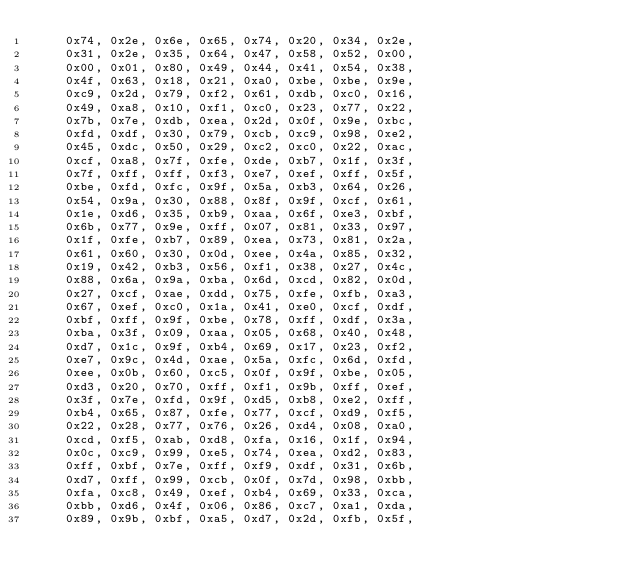Convert code to text. <code><loc_0><loc_0><loc_500><loc_500><_C_>	0x74, 0x2e, 0x6e, 0x65, 0x74, 0x20, 0x34, 0x2e,
	0x31, 0x2e, 0x35, 0x64, 0x47, 0x58, 0x52, 0x00,
	0x00, 0x01, 0x80, 0x49, 0x44, 0x41, 0x54, 0x38,
	0x4f, 0x63, 0x18, 0x21, 0xa0, 0xbe, 0xbe, 0x9e,
	0xc9, 0x2d, 0x79, 0xf2, 0x61, 0xdb, 0xc0, 0x16,
	0x49, 0xa8, 0x10, 0xf1, 0xc0, 0x23, 0x77, 0x22,
	0x7b, 0x7e, 0xdb, 0xea, 0x2d, 0x0f, 0x9e, 0xbc,
	0xfd, 0xdf, 0x30, 0x79, 0xcb, 0xc9, 0x98, 0xe2,
	0x45, 0xdc, 0x50, 0x29, 0xc2, 0xc0, 0x22, 0xac,
	0xcf, 0xa8, 0x7f, 0xfe, 0xde, 0xb7, 0x1f, 0x3f,
	0x7f, 0xff, 0xff, 0xf3, 0xe7, 0xef, 0xff, 0x5f,
	0xbe, 0xfd, 0xfc, 0x9f, 0x5a, 0xb3, 0x64, 0x26,
	0x54, 0x9a, 0x30, 0x88, 0x8f, 0x9f, 0xcf, 0x61,
	0x1e, 0xd6, 0x35, 0xb9, 0xaa, 0x6f, 0xe3, 0xbf,
	0x6b, 0x77, 0x9e, 0xff, 0x07, 0x81, 0x33, 0x97,
	0x1f, 0xfe, 0xb7, 0x89, 0xea, 0x73, 0x81, 0x2a,
	0x61, 0x60, 0x30, 0x0d, 0xee, 0x4a, 0x85, 0x32,
	0x19, 0x42, 0xb3, 0x56, 0xf1, 0x38, 0x27, 0x4c,
	0x88, 0x6a, 0x9a, 0xba, 0x6d, 0xcd, 0x82, 0x0d,
	0x27, 0xcf, 0xae, 0xdd, 0x75, 0xfe, 0xfb, 0xa3,
	0x67, 0xef, 0xc0, 0x1a, 0x41, 0xe0, 0xcf, 0xdf,
	0xbf, 0xff, 0x9f, 0xbe, 0x78, 0xff, 0xdf, 0x3a,
	0xba, 0x3f, 0x09, 0xaa, 0x05, 0x68, 0x40, 0x48,
	0xd7, 0x1c, 0x9f, 0xb4, 0x69, 0x17, 0x23, 0xf2,
	0xe7, 0x9c, 0x4d, 0xae, 0x5a, 0xfc, 0x6d, 0xfd,
	0xee, 0x0b, 0x60, 0xc5, 0x0f, 0x9f, 0xbe, 0x05,
	0xd3, 0x20, 0x70, 0xff, 0xf1, 0x9b, 0xff, 0xef,
	0x3f, 0x7e, 0xfd, 0x9f, 0xd5, 0xb8, 0xe2, 0xff,
	0xb4, 0x65, 0x87, 0xfe, 0x77, 0xcf, 0xd9, 0xf5,
	0x22, 0x28, 0x77, 0x76, 0x26, 0xd4, 0x08, 0xa0,
	0xcd, 0xf5, 0xab, 0xd8, 0xfa, 0x16, 0x1f, 0x94,
	0x0c, 0xc9, 0x99, 0xe5, 0x74, 0xea, 0xd2, 0x83,
	0xff, 0xbf, 0x7e, 0xff, 0xf9, 0xdf, 0x31, 0x6b,
	0xd7, 0xff, 0x99, 0xcb, 0x0f, 0x7d, 0x98, 0xbb,
	0xfa, 0xc8, 0x49, 0xef, 0xb4, 0x69, 0x33, 0xca,
	0xbb, 0xd6, 0x4f, 0x06, 0x86, 0xc7, 0xa1, 0xda,
	0x89, 0x9b, 0xbf, 0xa5, 0xd7, 0x2d, 0xfb, 0x5f,</code> 